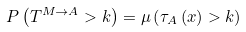Convert formula to latex. <formula><loc_0><loc_0><loc_500><loc_500>P \left ( T ^ { M \rightarrow A } > k \right ) = \mu \left ( \tau _ { A } \left ( x \right ) > k \right )</formula> 